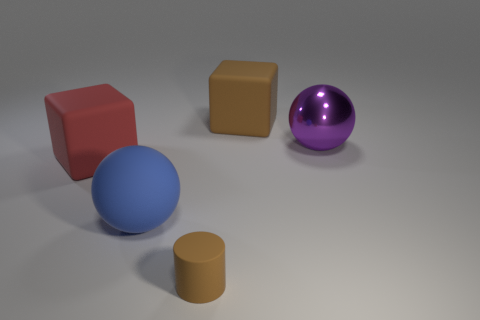Are there any other things that have the same material as the purple sphere?
Give a very brief answer. No. There is another metallic thing that is the same size as the blue thing; what shape is it?
Ensure brevity in your answer.  Sphere. What number of green objects are large metallic balls or large matte spheres?
Your response must be concise. 0. What number of metal things have the same size as the matte sphere?
Your answer should be compact. 1. There is a thing that is the same color as the cylinder; what shape is it?
Your answer should be compact. Cube. What number of things are tiny objects or large rubber balls in front of the red block?
Keep it short and to the point. 2. Do the rubber thing behind the big metal object and the brown matte thing that is in front of the red matte cube have the same size?
Your answer should be compact. No. What number of other red objects are the same shape as the small rubber thing?
Your answer should be very brief. 0. There is a big brown object that is the same material as the big red object; what is its shape?
Offer a very short reply. Cube. There is a block on the right side of the big block that is in front of the block right of the blue rubber ball; what is it made of?
Your response must be concise. Rubber. 